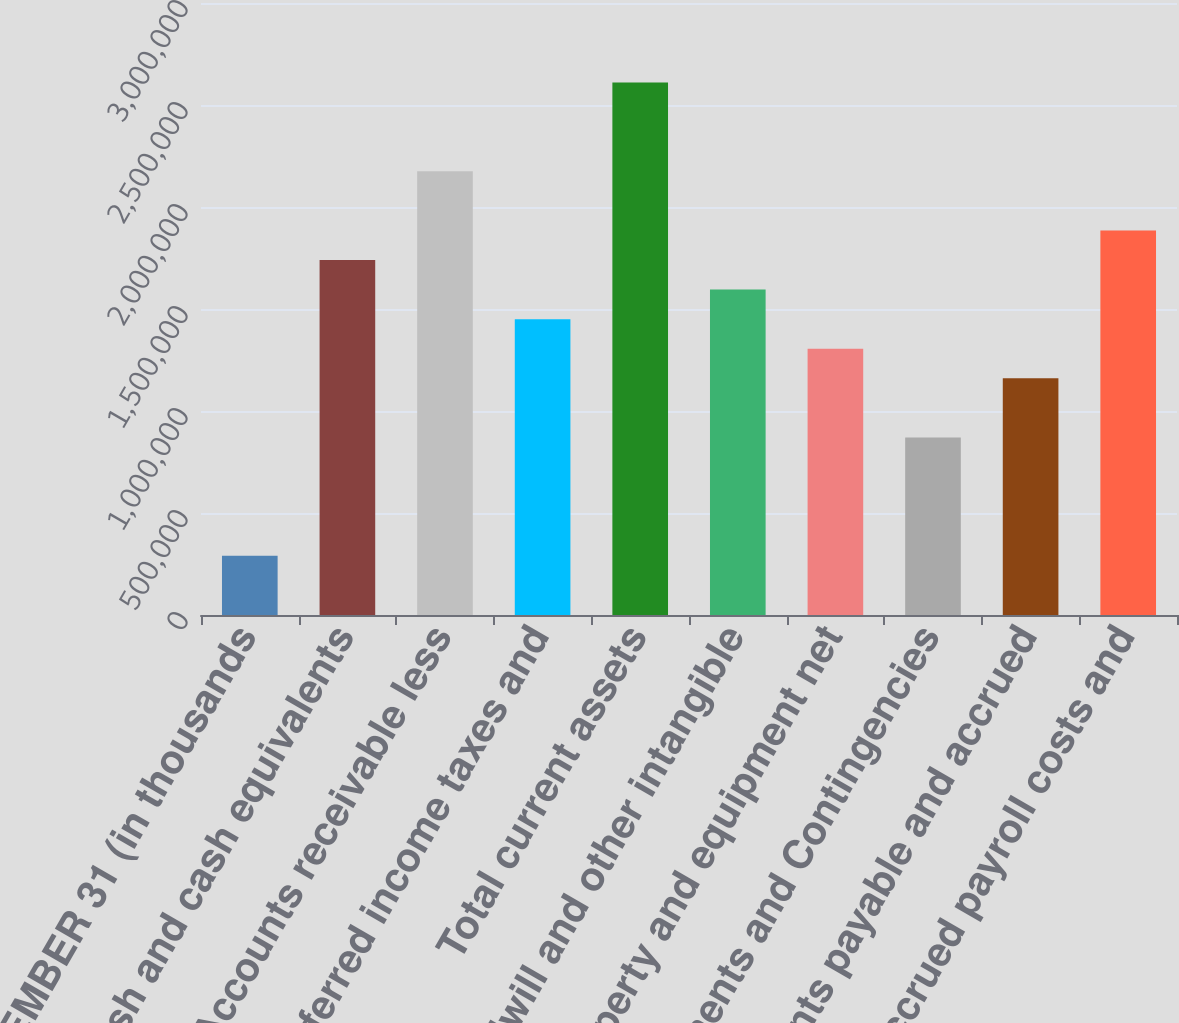Convert chart to OTSL. <chart><loc_0><loc_0><loc_500><loc_500><bar_chart><fcel>DECEMBER 31 (in thousands<fcel>Cash and cash equivalents<fcel>Accounts receivable less<fcel>Deferred income taxes and<fcel>Total current assets<fcel>Goodwill and other intangible<fcel>Property and equipment net<fcel>Commitments and Contingencies<fcel>Accounts payable and accrued<fcel>Accrued payroll costs and<nl><fcel>290186<fcel>1.74033e+06<fcel>2.17537e+06<fcel>1.4503e+06<fcel>2.61041e+06<fcel>1.59531e+06<fcel>1.30528e+06<fcel>870242<fcel>1.16027e+06<fcel>1.88534e+06<nl></chart> 